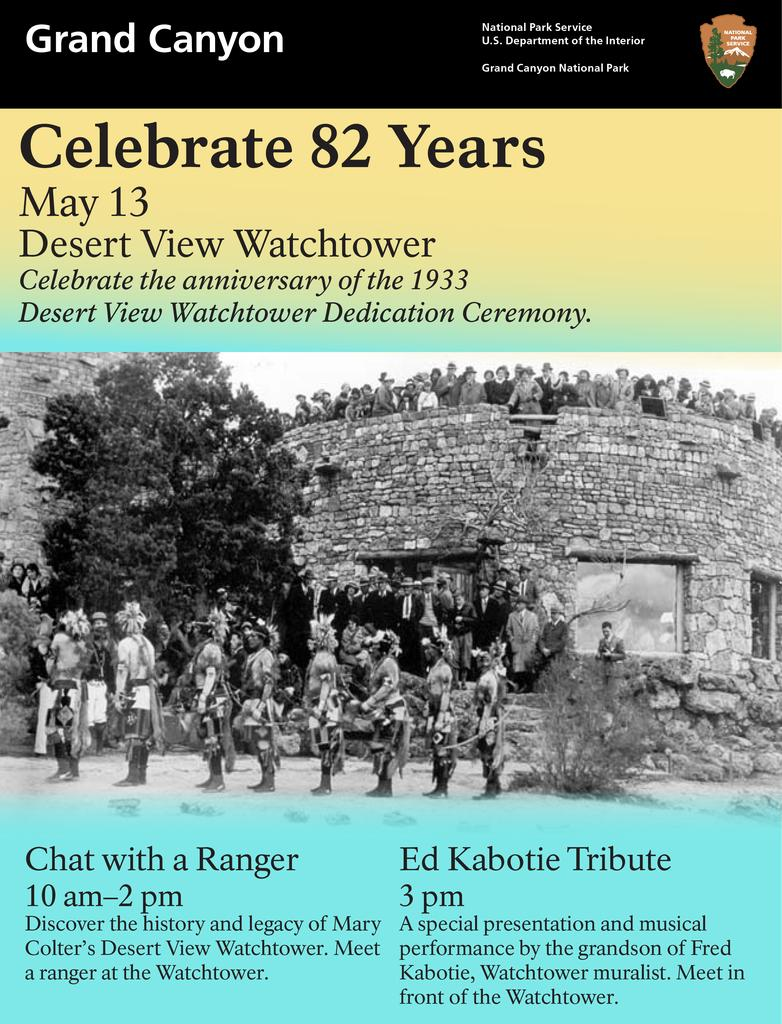<image>
Write a terse but informative summary of the picture. 82 years are being celebrated on this poster. 